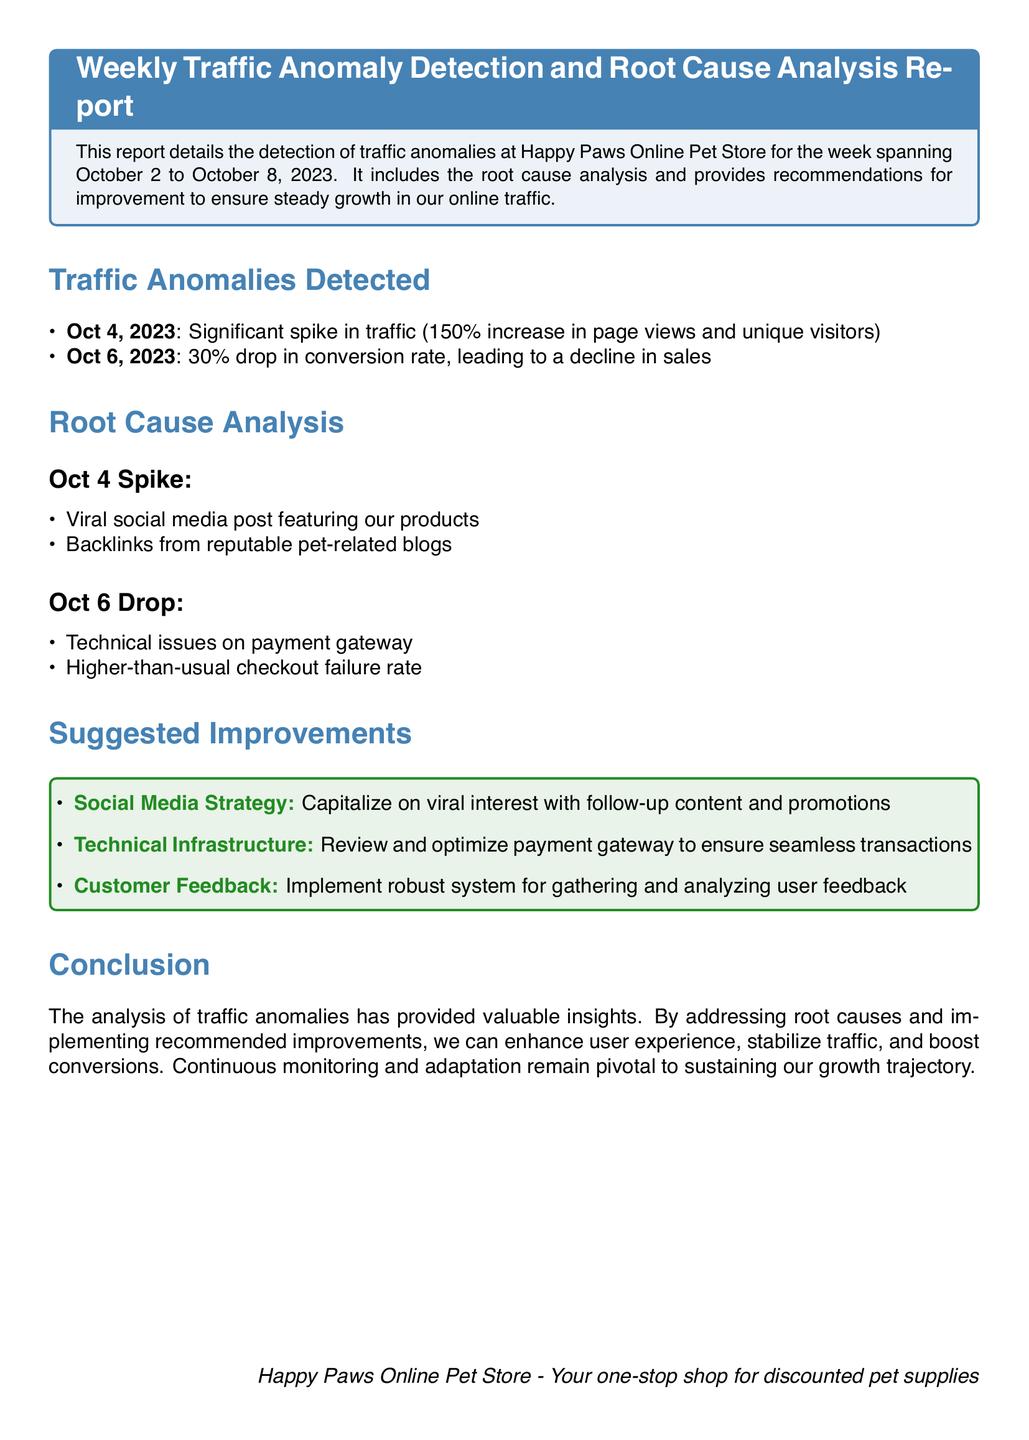What were the dates of the report? The report covers the week spanning from October 2 to October 8, 2023.
Answer: October 2 to October 8, 2023 What percentage increase in traffic was detected on October 4? The significant spike in traffic on October 4 was a 150% increase in page views and unique visitors.
Answer: 150% What was the conversion rate drop on October 6? There was a 30% drop in conversion rate on October 6, leading to a decline in sales.
Answer: 30% What caused the spike in traffic on October 4? The spike in traffic was caused by a viral social media post featuring the products and backlinks from reputable blogs.
Answer: Viral social media post and backlinks What were the issues identified on October 6? The technical issues identified included problems with the payment gateway and higher-than-usual checkout failure rate.
Answer: Payment gateway issues and checkout failures What is one of the suggested improvements related to social media? One suggested improvement is to capitalize on viral interest with follow-up content and promotions.
Answer: Follow-up content and promotions What does the report suggest for technical infrastructure? The report recommends reviewing and optimizing the payment gateway to ensure seamless transactions.
Answer: Optimize payment gateway What type of system is suggested for gathering user feedback? The report suggests implementing a robust system for gathering and analyzing user feedback.
Answer: Robust feedback system What is the conclusion of the report regarding growth? The conclusion emphasizes that continuous monitoring and adaptation are pivotal to sustaining growth.
Answer: Continuous monitoring and adaptation 